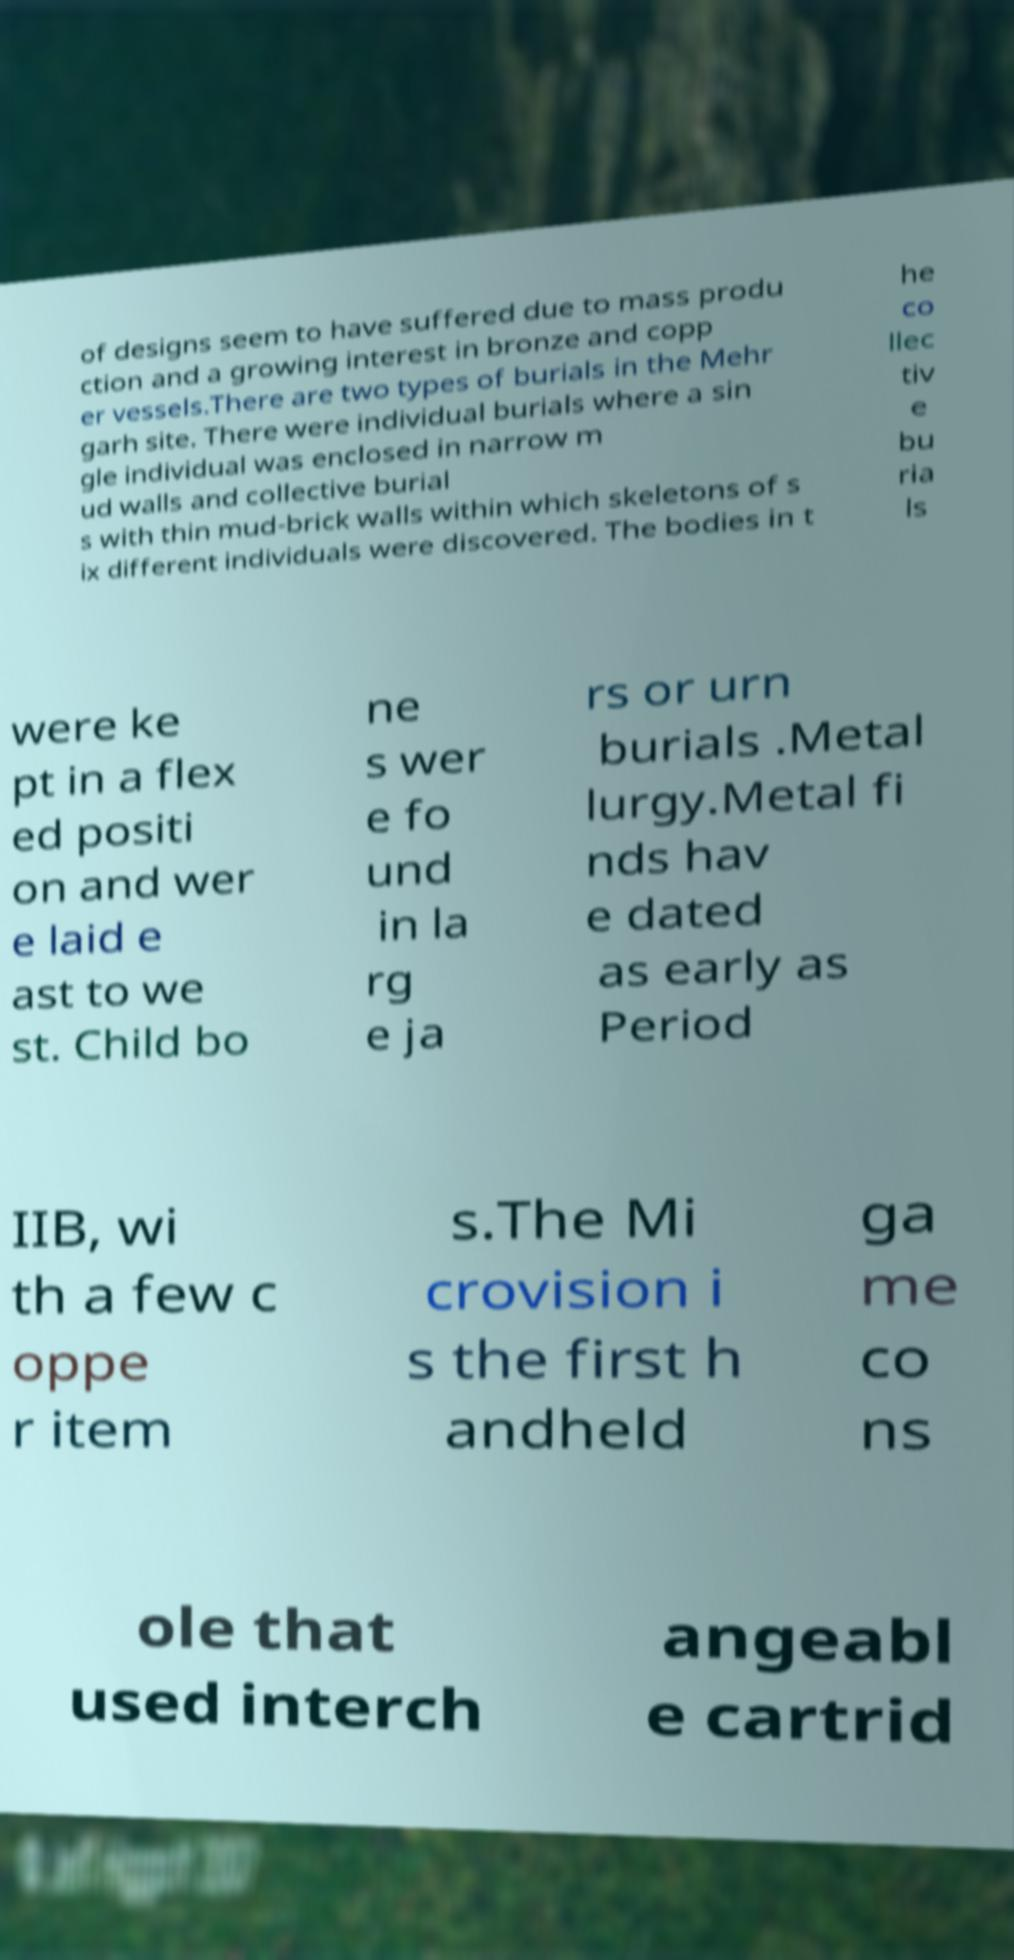I need the written content from this picture converted into text. Can you do that? of designs seem to have suffered due to mass produ ction and a growing interest in bronze and copp er vessels.There are two types of burials in the Mehr garh site. There were individual burials where a sin gle individual was enclosed in narrow m ud walls and collective burial s with thin mud-brick walls within which skeletons of s ix different individuals were discovered. The bodies in t he co llec tiv e bu ria ls were ke pt in a flex ed positi on and wer e laid e ast to we st. Child bo ne s wer e fo und in la rg e ja rs or urn burials .Metal lurgy.Metal fi nds hav e dated as early as Period IIB, wi th a few c oppe r item s.The Mi crovision i s the first h andheld ga me co ns ole that used interch angeabl e cartrid 